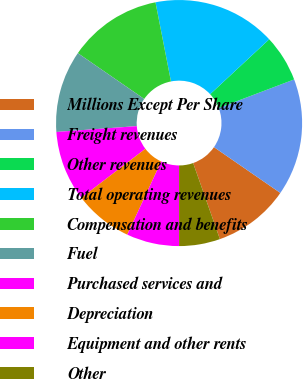Convert chart. <chart><loc_0><loc_0><loc_500><loc_500><pie_chart><fcel>Millions Except Per Share<fcel>Freight revenues<fcel>Other revenues<fcel>Total operating revenues<fcel>Compensation and benefits<fcel>Fuel<fcel>Purchased services and<fcel>Depreciation<fcel>Equipment and other rents<fcel>Other<nl><fcel>10.0%<fcel>15.38%<fcel>6.15%<fcel>16.15%<fcel>12.31%<fcel>10.77%<fcel>9.23%<fcel>7.69%<fcel>6.92%<fcel>5.38%<nl></chart> 